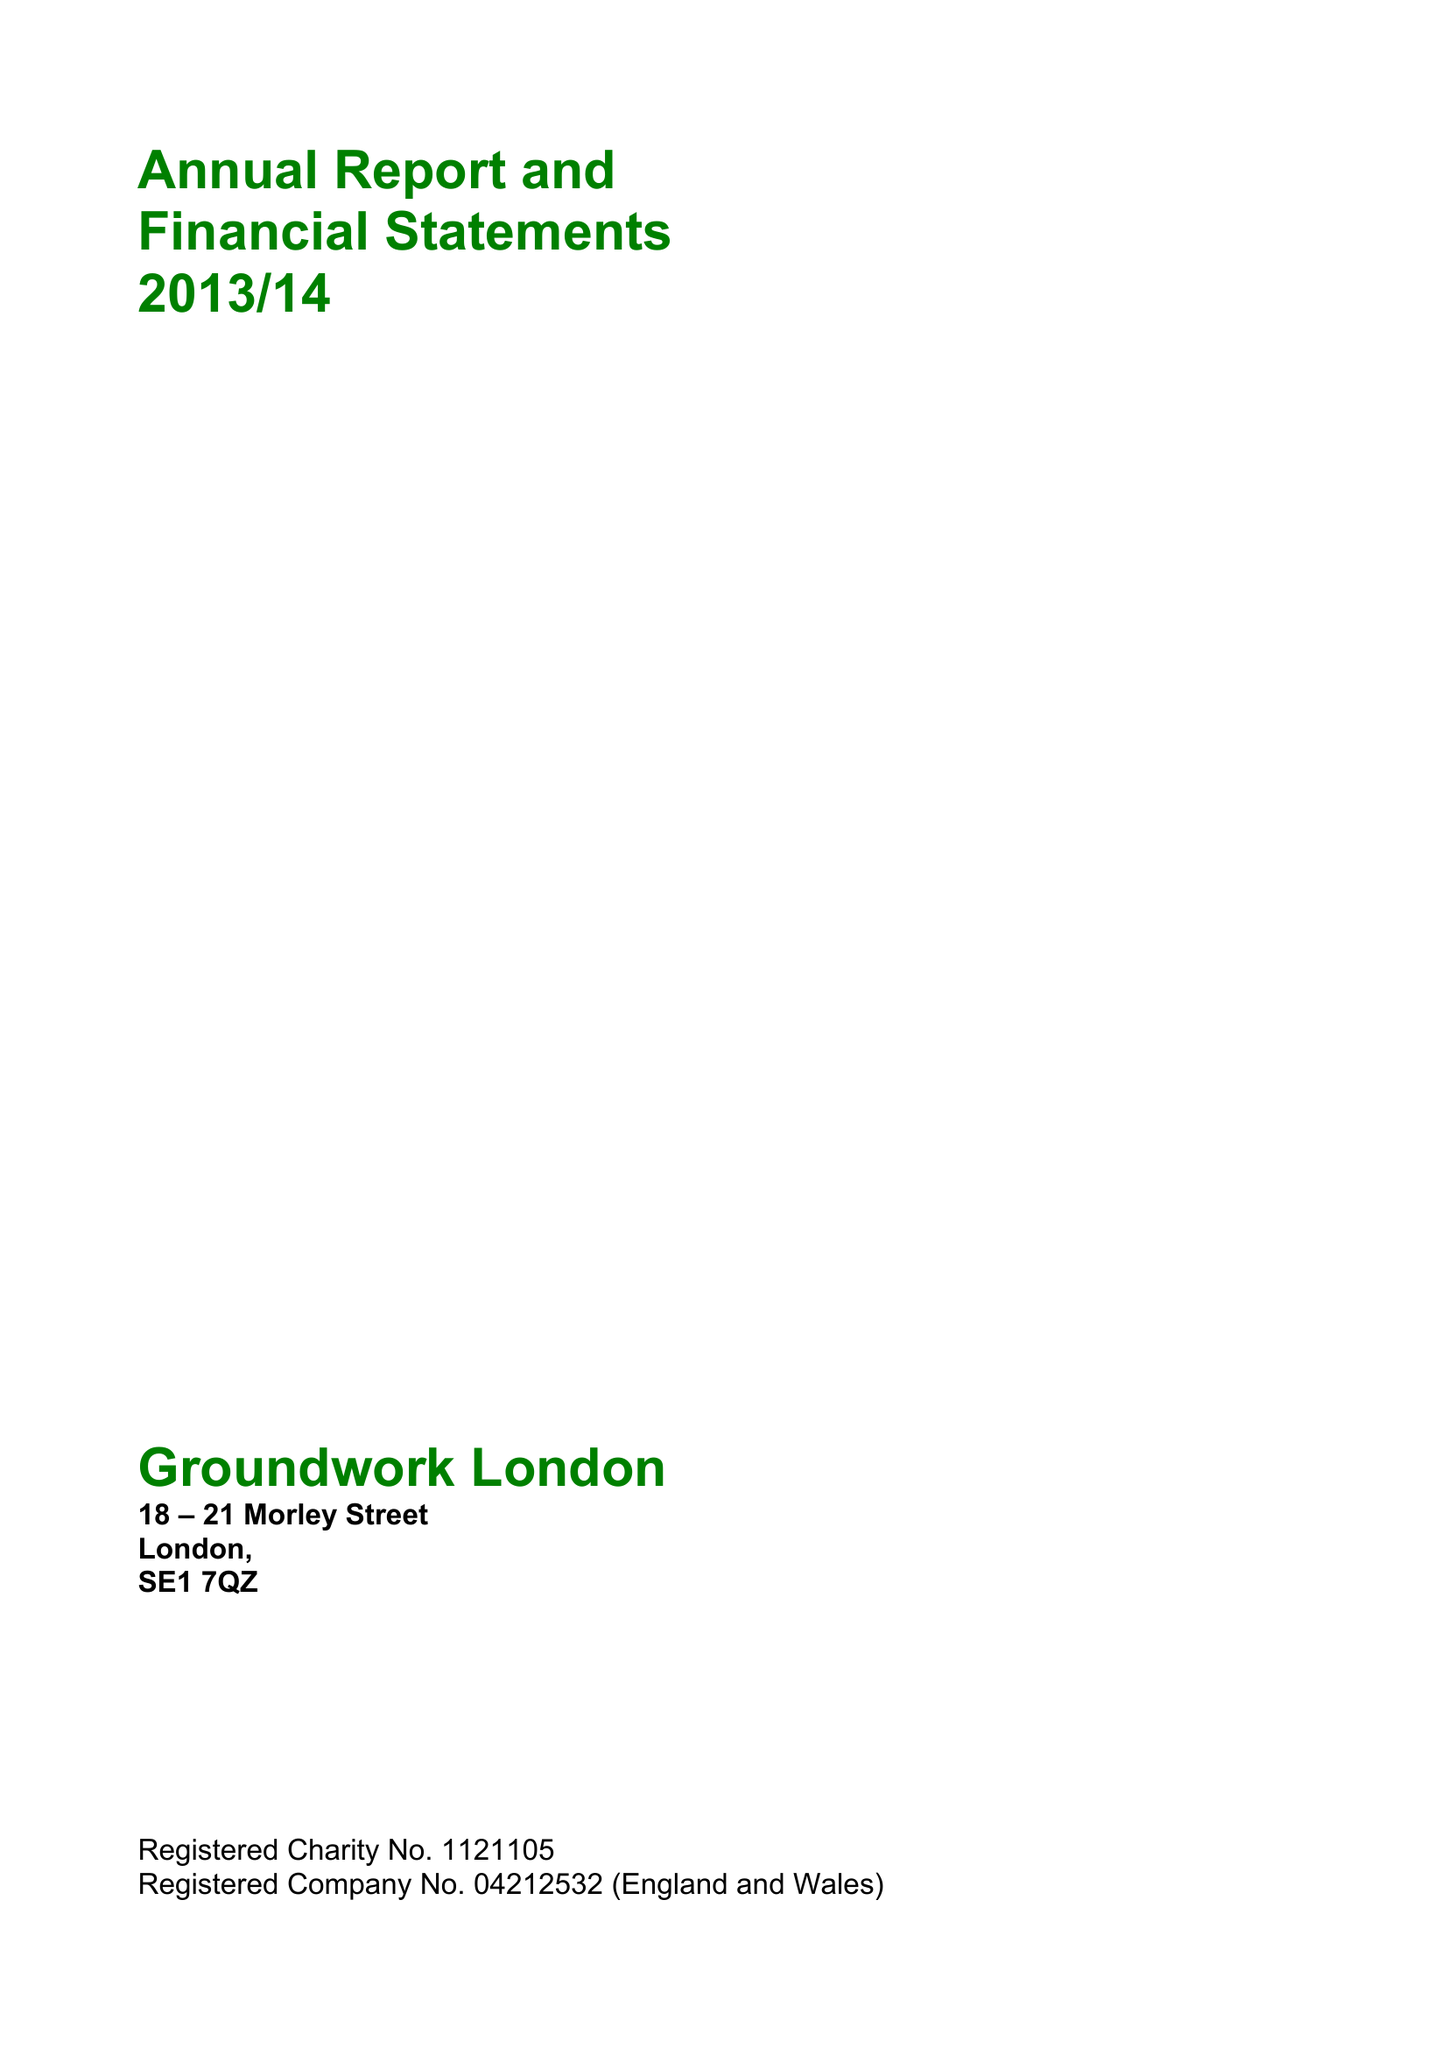What is the value for the income_annually_in_british_pounds?
Answer the question using a single word or phrase. 10436027.00 